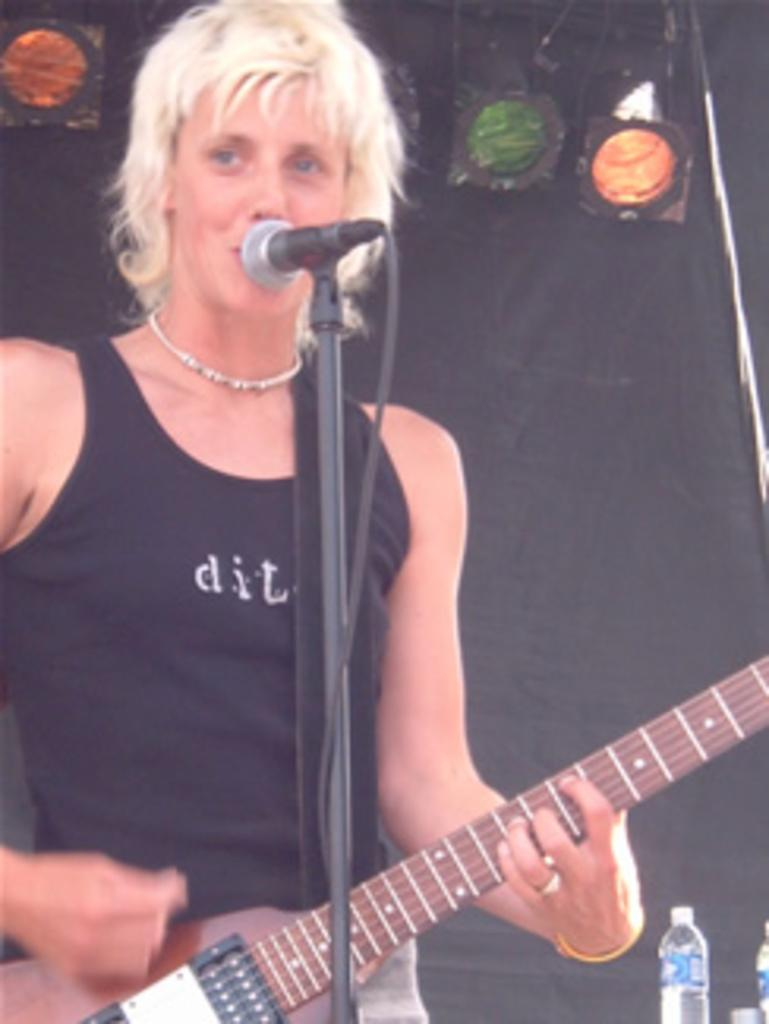Who is the main subject in the image? There is a lady in the center of the image. What is the lady holding in the image? The lady is holding a guitar. What object is in front of the lady? There is a microphone in front of the lady. Can you identify any other objects in the image? Yes, there is a water bottle on the right side of the image. What type of horn can be seen on the lady's head in the image? There is no horn present on the lady's head in the image. 